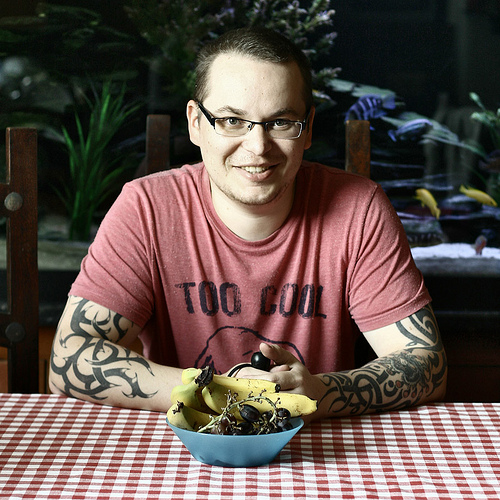Read all the text in this image. TOO COOL 